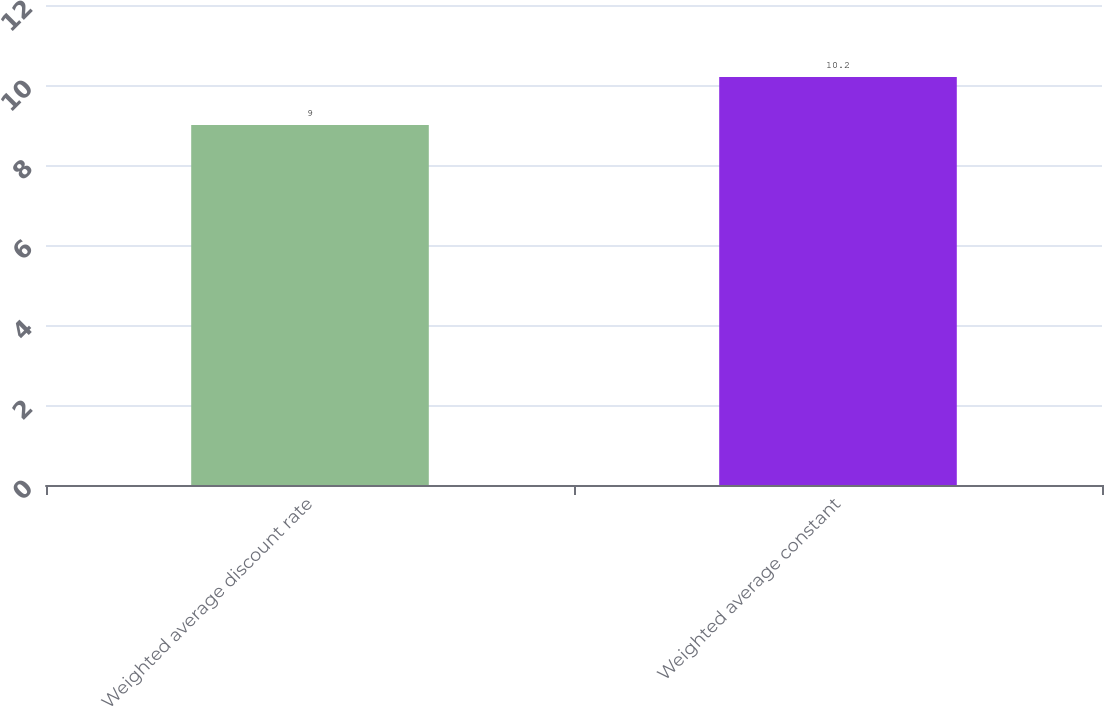Convert chart. <chart><loc_0><loc_0><loc_500><loc_500><bar_chart><fcel>Weighted average discount rate<fcel>Weighted average constant<nl><fcel>9<fcel>10.2<nl></chart> 